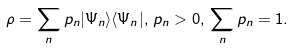<formula> <loc_0><loc_0><loc_500><loc_500>\rho = \sum _ { n } p _ { n } | \Psi _ { n } \rangle \langle \Psi _ { n } | , \, p _ { n } > 0 , \, \sum _ { n } p _ { n } = 1 .</formula> 